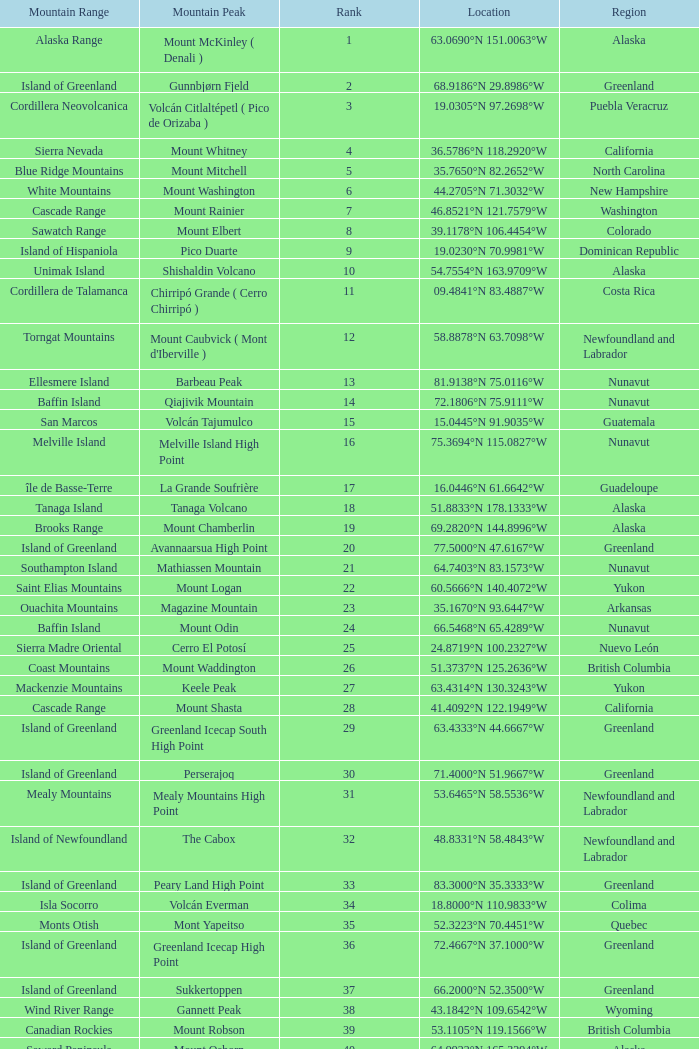Which Mountain Range has a Region of haiti, and a Location of 18.3601°n 71.9764°w? Island of Hispaniola. 